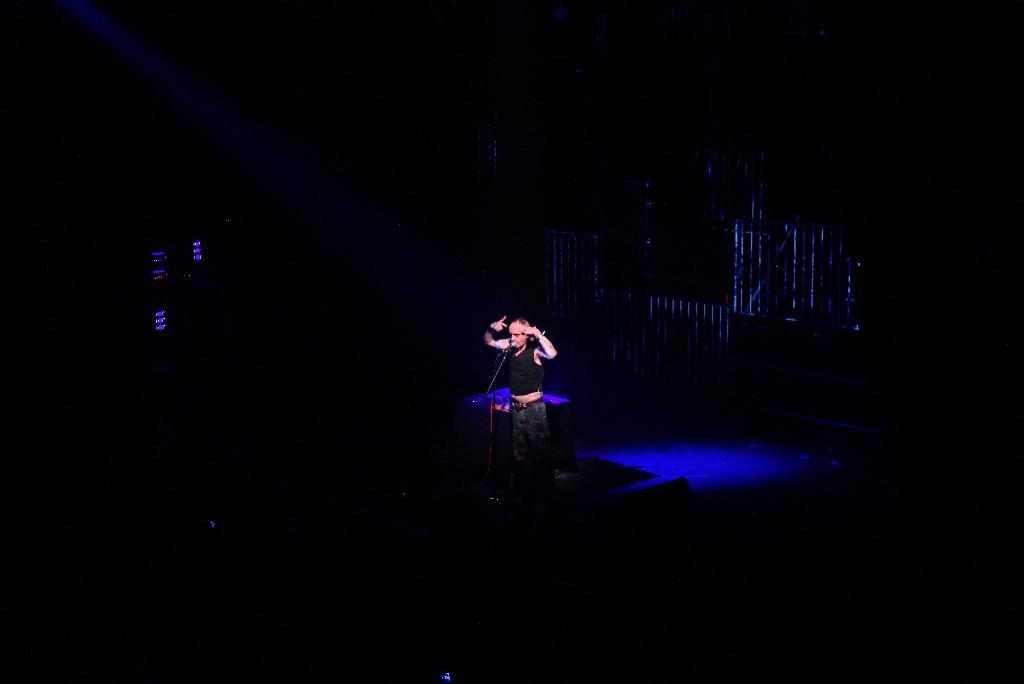What is the main subject of the image? There is a person in the image. What is the person doing in the image? The person is standing in front of a mic and stand. What type of lighting is used in the image? There is blue color light behind the person. How would you describe the overall appearance of the image? The background of the image is dark. How many friends does the person have in the image? There is no information about friends in the image; it only shows a person standing in front of a mic and stand with blue light behind them. 